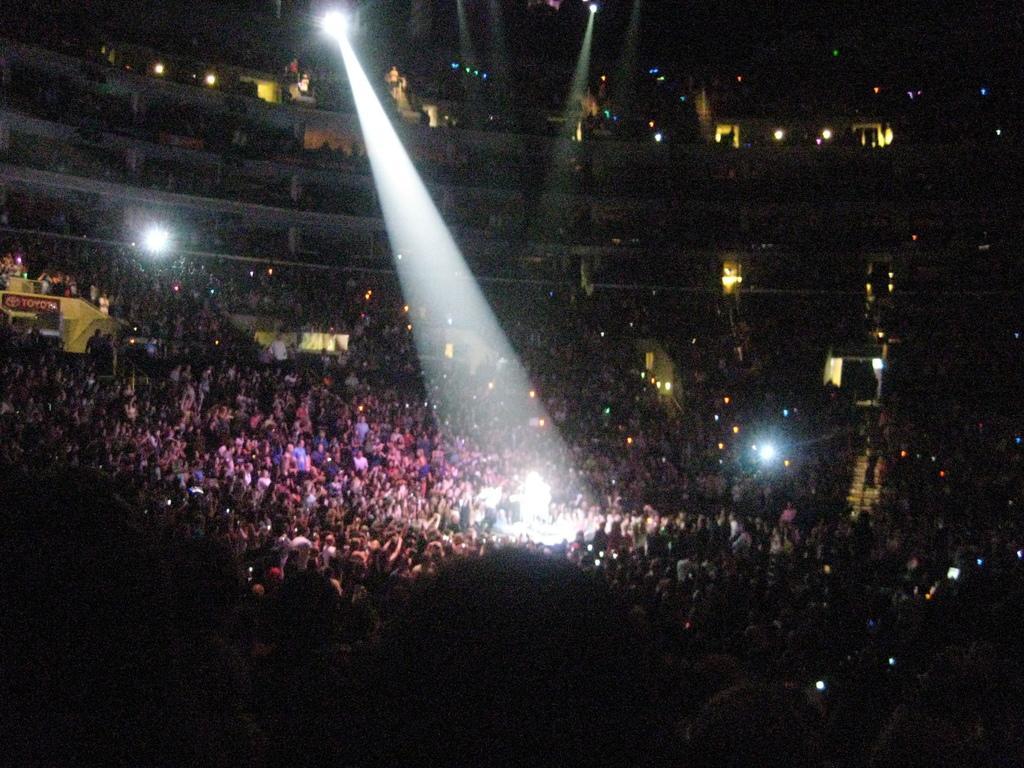Describe this image in one or two sentences. In this image, I can see groups of people. This looks like a show light. I think this is a stage show. This picture was taken inside the building. These are the lights. 